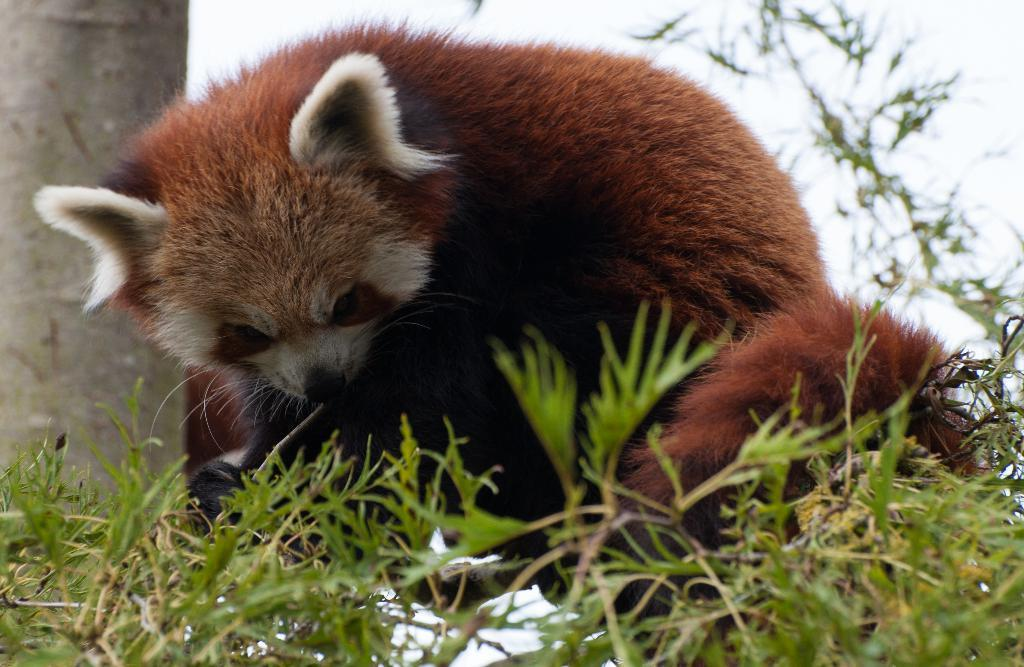What type of living creature is in the image? There is an animal in the image. What is in front of the animal? There are plants in front of the animal. What is behind the animal? There are walls behind the animal. What type of shirt is the animal wearing in the image? There is no shirt present in the image, as the subject is an animal. 